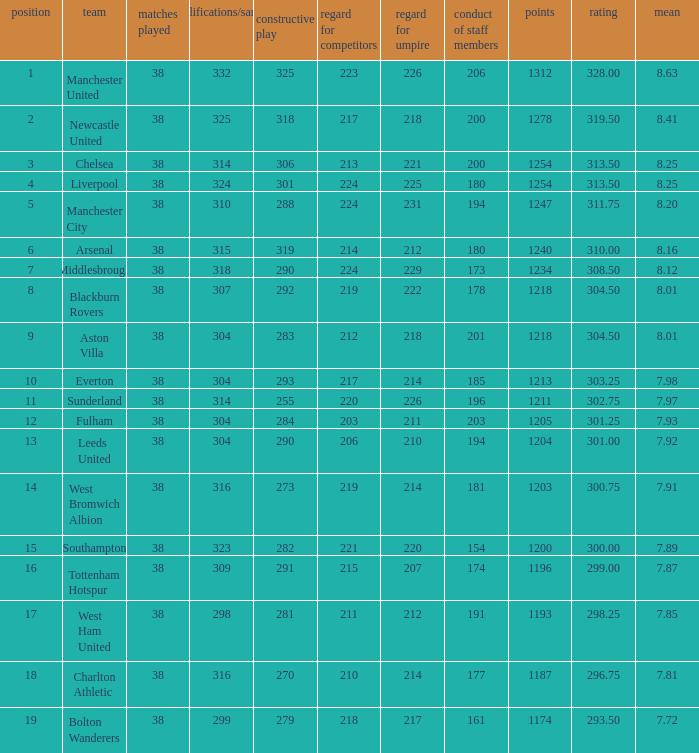Name the most red/yellow cards for positive play being 255 314.0. 